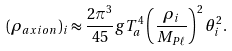Convert formula to latex. <formula><loc_0><loc_0><loc_500><loc_500>( \rho _ { a x i o n } ) _ { i } \approx \frac { 2 \pi ^ { 3 } } { 4 5 } g T ^ { 4 } _ { a } \left ( \frac { \rho _ { i } } { M _ { P \ell } } \right ) ^ { 2 } \theta _ { i } ^ { 2 } .</formula> 